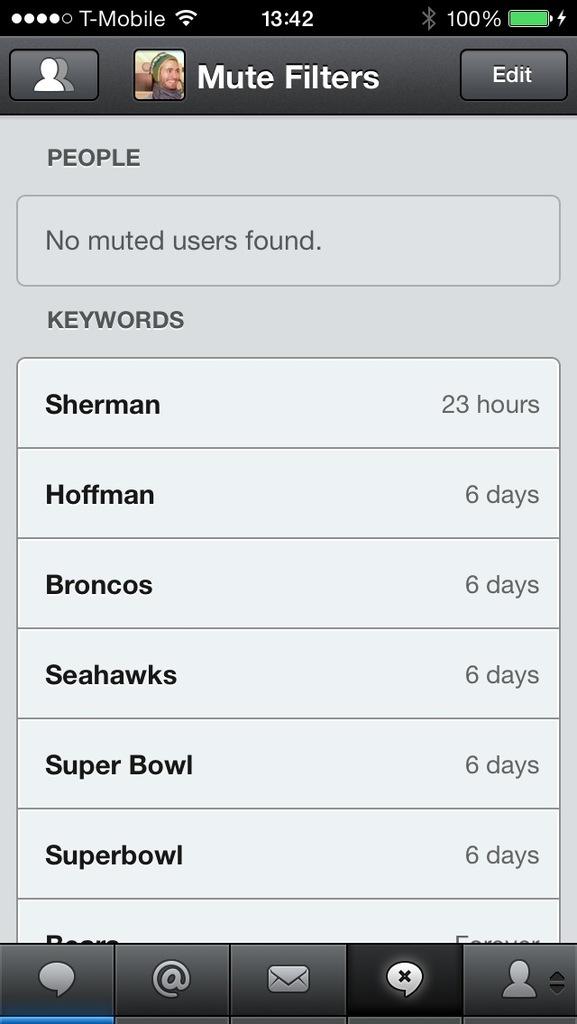What time is it?
Provide a short and direct response. 13:42. Who's profile is this?
Provide a short and direct response. Unanswerable. 